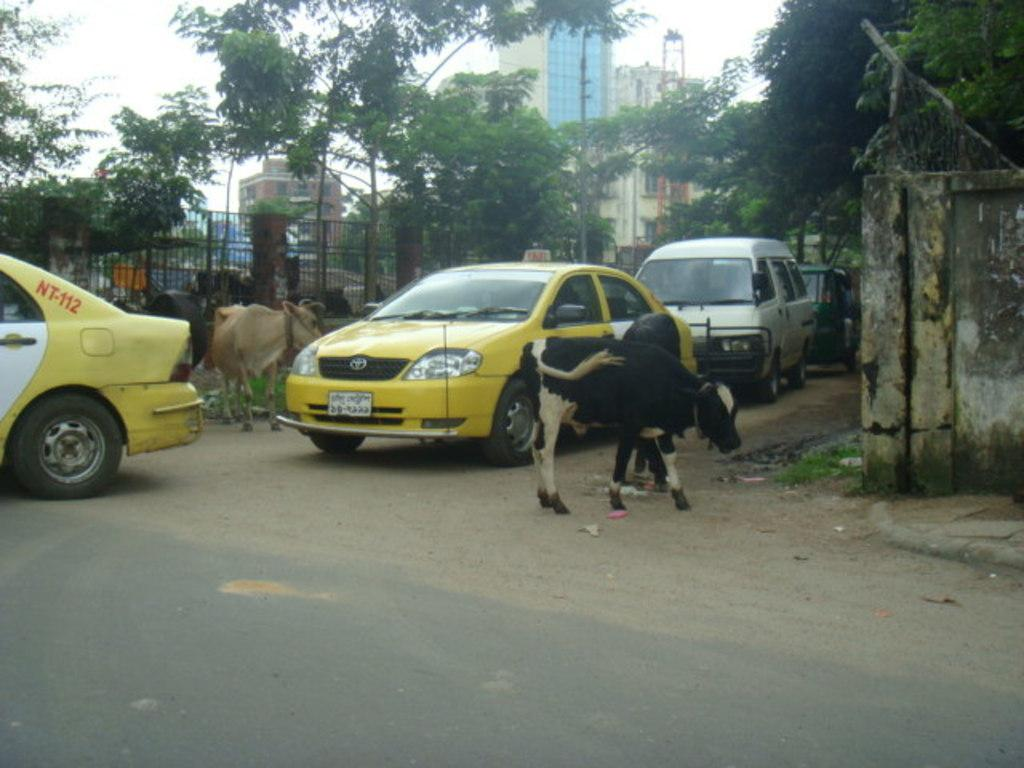<image>
Provide a brief description of the given image. Several small calf's are on both sides of two taxi cabs, one marked as NT-112. 